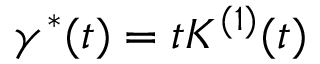<formula> <loc_0><loc_0><loc_500><loc_500>\gamma ^ { * } ( t ) = t K ^ { ( 1 ) } ( t )</formula> 